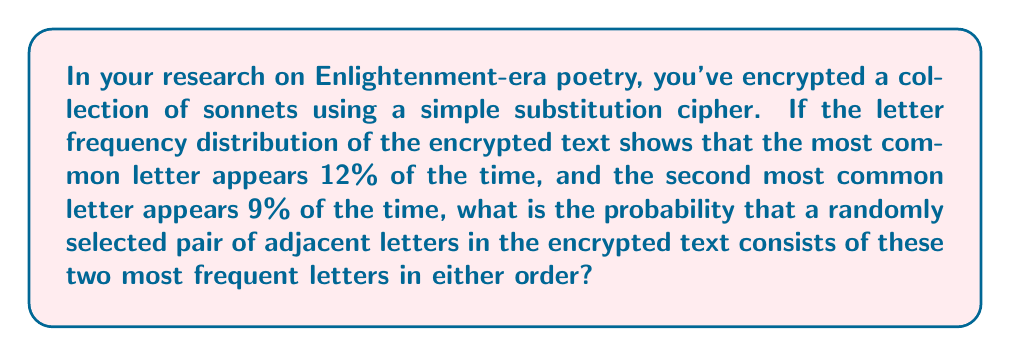What is the answer to this math problem? Let's approach this step-by-step:

1) Let's denote the most common letter as A (12%) and the second most common as B (9%).

2) The probability of selecting A is 0.12, and the probability of selecting B is 0.09.

3) We need to consider two scenarios:
   a) A followed by B
   b) B followed by A

4) For scenario a):
   P(A followed by B) = P(A) * P(B) = 0.12 * 0.09 = 0.0108

5) For scenario b):
   P(B followed by A) = P(B) * P(A) = 0.09 * 0.12 = 0.0108

6) The total probability is the sum of these two scenarios:
   P(total) = P(A followed by B) + P(B followed by A)
            = 0.0108 + 0.0108 = 0.0216

7) To express this as a percentage:
   0.0216 * 100% = 2.16%

Therefore, the probability is 2.16% or 0.0216.
Answer: 0.0216 